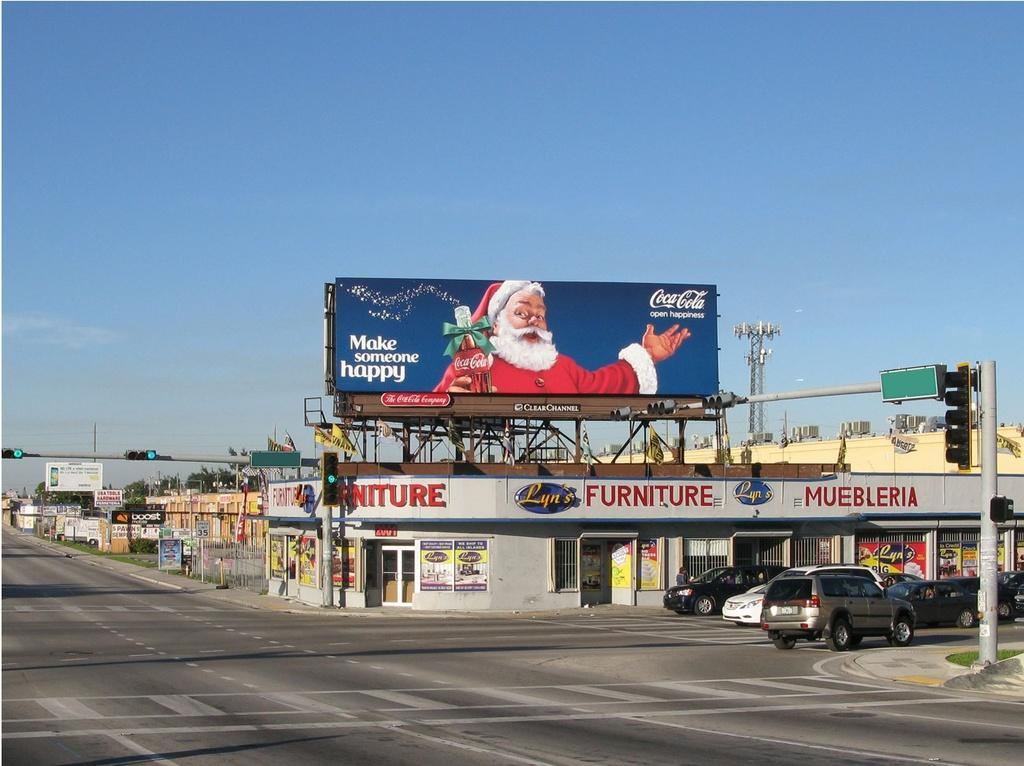<image>
Provide a brief description of the given image. A Christmas-themed billboard for Coke is above a furniture store. 